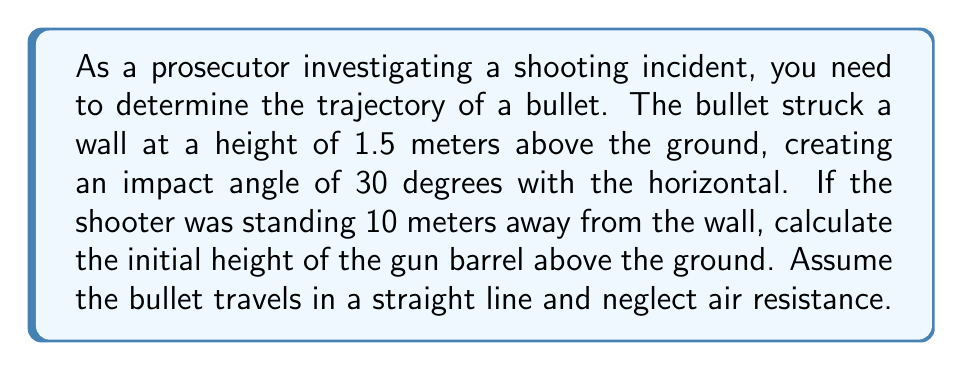Can you answer this question? To solve this inverse problem and determine the initial height of the gun barrel, we'll use trigonometry and the given information. Let's approach this step-by-step:

1) First, let's visualize the problem:

[asy]
import geometry;

unitsize(1cm);

pair A = (0,0);
pair B = (10,0);
pair C = (10,1.5);
pair D = (0,1.5);

draw(A--B--C--D--A);
draw(A--(10,3.27), arrow=Arrow(TeXHead));

label("Ground", (5,-0.3));
label("Wall", (10.3,0.75));
label("10 m", (5,-0.7));
label("1.5 m", (10.5,0.75));
label("30°", (9.7,1.7), E);
label("h", (-0.3,0.75));

dot("Impact point", C, NE);
dot("Shooter", A, SW);
[/asy]

2) Let's define our variables:
   $h$ = initial height of the gun barrel (what we're solving for)
   $x$ = horizontal distance to the wall (10 meters)
   $y$ = height of impact point (1.5 meters)
   $\theta$ = angle of impact with the horizontal (30 degrees)

3) The tangent of the angle is the ratio of the vertical rise to the horizontal run:

   $$\tan(\theta) = \frac{y - h}{x}$$

4) We know $\theta = 30°$, so we can use the known value of $\tan(30°) = \frac{1}{\sqrt{3}}$:

   $$\frac{1}{\sqrt{3}} = \frac{1.5 - h}{10}$$

5) Cross-multiply:

   $$10 \cdot \frac{1}{\sqrt{3}} = 1.5 - h$$

6) Simplify:

   $$\frac{10}{\sqrt{3}} = 1.5 - h$$

7) Solve for $h$:

   $$h = 1.5 - \frac{10}{\sqrt{3}}$$

8) Calculate the value:

   $$h = 1.5 - \frac{10}{\sqrt{3}} \approx -4.27$$

9) The negative value indicates that the initial height of the gun barrel was 4.27 meters below ground level, which is not physically possible in this scenario. This suggests that the shooter was likely in an elevated position.

10) To find the height above ground, we take the absolute value:

    $$h = |1.5 - \frac{10}{\sqrt{3}}| \approx 4.27$$

Therefore, the initial height of the gun barrel was approximately 4.27 meters above the ground.
Answer: 4.27 meters 